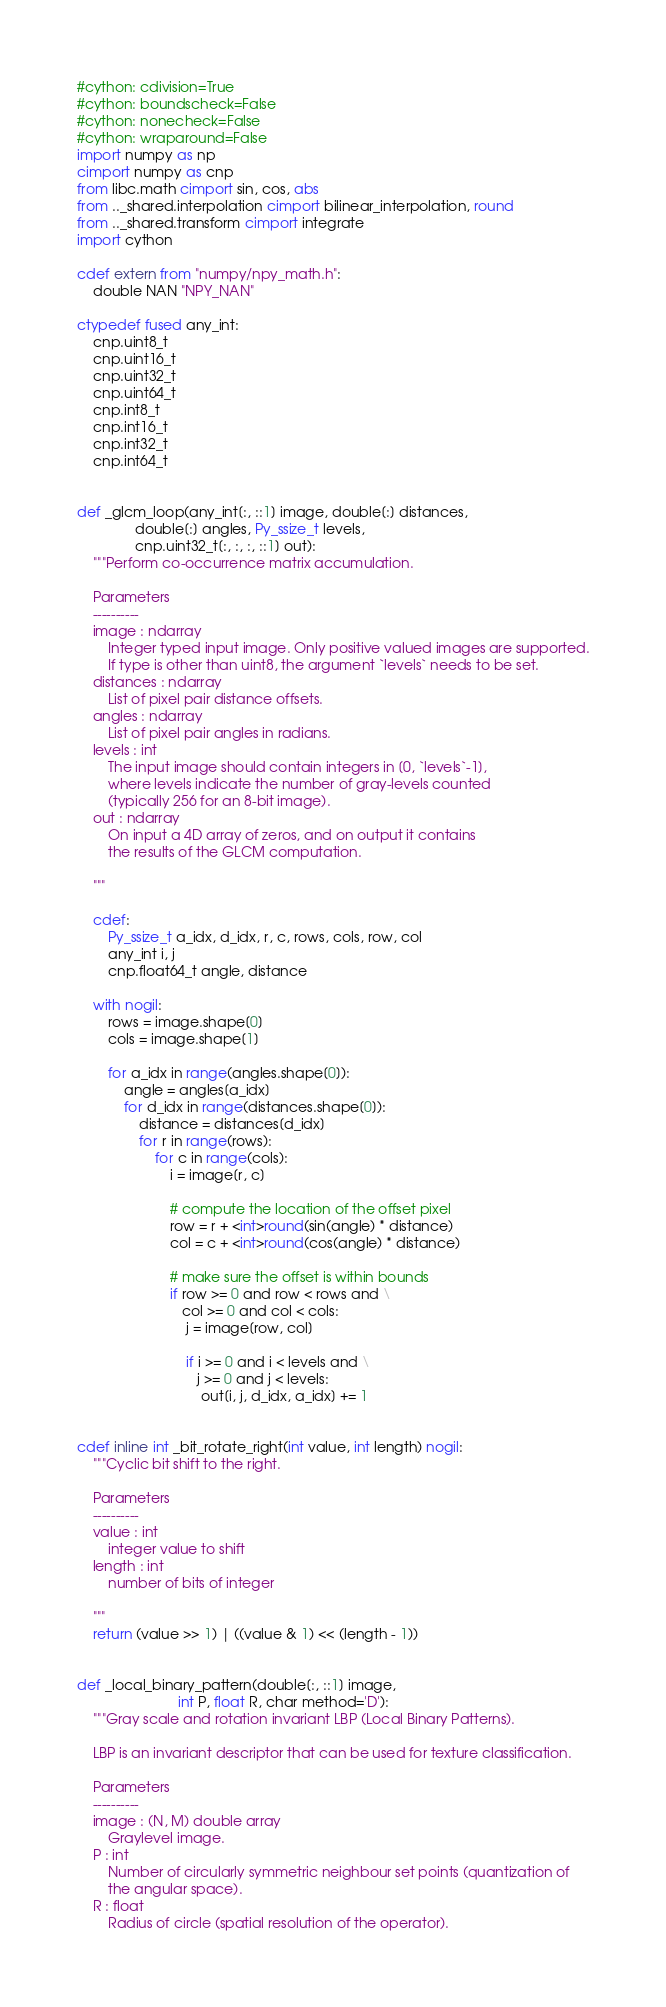Convert code to text. <code><loc_0><loc_0><loc_500><loc_500><_Cython_>#cython: cdivision=True
#cython: boundscheck=False
#cython: nonecheck=False
#cython: wraparound=False
import numpy as np
cimport numpy as cnp
from libc.math cimport sin, cos, abs
from .._shared.interpolation cimport bilinear_interpolation, round
from .._shared.transform cimport integrate
import cython

cdef extern from "numpy/npy_math.h":
    double NAN "NPY_NAN"

ctypedef fused any_int:
    cnp.uint8_t
    cnp.uint16_t
    cnp.uint32_t
    cnp.uint64_t
    cnp.int8_t
    cnp.int16_t
    cnp.int32_t
    cnp.int64_t


def _glcm_loop(any_int[:, ::1] image, double[:] distances,
               double[:] angles, Py_ssize_t levels,
               cnp.uint32_t[:, :, :, ::1] out):
    """Perform co-occurrence matrix accumulation.

    Parameters
    ----------
    image : ndarray
        Integer typed input image. Only positive valued images are supported.
        If type is other than uint8, the argument `levels` needs to be set.
    distances : ndarray
        List of pixel pair distance offsets.
    angles : ndarray
        List of pixel pair angles in radians.
    levels : int
        The input image should contain integers in [0, `levels`-1],
        where levels indicate the number of gray-levels counted
        (typically 256 for an 8-bit image).
    out : ndarray
        On input a 4D array of zeros, and on output it contains
        the results of the GLCM computation.

    """

    cdef:
        Py_ssize_t a_idx, d_idx, r, c, rows, cols, row, col
        any_int i, j
        cnp.float64_t angle, distance

    with nogil:
        rows = image.shape[0]
        cols = image.shape[1]

        for a_idx in range(angles.shape[0]):
            angle = angles[a_idx]
            for d_idx in range(distances.shape[0]):
                distance = distances[d_idx]
                for r in range(rows):
                    for c in range(cols):
                        i = image[r, c]

                        # compute the location of the offset pixel
                        row = r + <int>round(sin(angle) * distance)
                        col = c + <int>round(cos(angle) * distance)

                        # make sure the offset is within bounds
                        if row >= 0 and row < rows and \
                           col >= 0 and col < cols:
                            j = image[row, col]

                            if i >= 0 and i < levels and \
                               j >= 0 and j < levels:
                                out[i, j, d_idx, a_idx] += 1


cdef inline int _bit_rotate_right(int value, int length) nogil:
    """Cyclic bit shift to the right.

    Parameters
    ----------
    value : int
        integer value to shift
    length : int
        number of bits of integer

    """
    return (value >> 1) | ((value & 1) << (length - 1))


def _local_binary_pattern(double[:, ::1] image,
                          int P, float R, char method='D'):
    """Gray scale and rotation invariant LBP (Local Binary Patterns).

    LBP is an invariant descriptor that can be used for texture classification.

    Parameters
    ----------
    image : (N, M) double array
        Graylevel image.
    P : int
        Number of circularly symmetric neighbour set points (quantization of
        the angular space).
    R : float
        Radius of circle (spatial resolution of the operator).</code> 